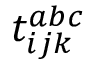<formula> <loc_0><loc_0><loc_500><loc_500>t _ { i j k } ^ { a b c }</formula> 